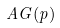<formula> <loc_0><loc_0><loc_500><loc_500>A G ( p )</formula> 